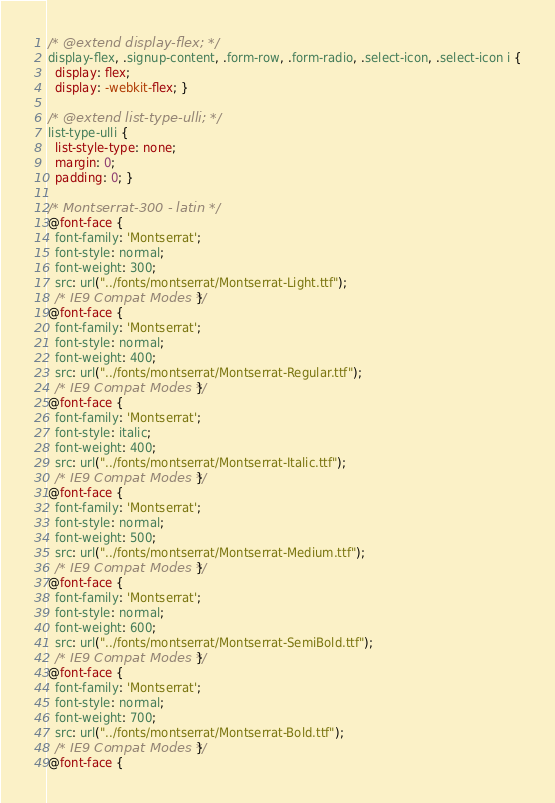Convert code to text. <code><loc_0><loc_0><loc_500><loc_500><_CSS_>/* @extend display-flex; */
display-flex, .signup-content, .form-row, .form-radio, .select-icon, .select-icon i {
  display: flex;
  display: -webkit-flex; }

/* @extend list-type-ulli; */
list-type-ulli {
  list-style-type: none;
  margin: 0;
  padding: 0; }

/* Montserrat-300 - latin */
@font-face {
  font-family: 'Montserrat';
  font-style: normal;
  font-weight: 300;
  src: url("../fonts/montserrat/Montserrat-Light.ttf");
  /* IE9 Compat Modes */ }
@font-face {
  font-family: 'Montserrat';
  font-style: normal;
  font-weight: 400;
  src: url("../fonts/montserrat/Montserrat-Regular.ttf");
  /* IE9 Compat Modes */ }
@font-face {
  font-family: 'Montserrat';
  font-style: italic;
  font-weight: 400;
  src: url("../fonts/montserrat/Montserrat-Italic.ttf");
  /* IE9 Compat Modes */ }
@font-face {
  font-family: 'Montserrat';
  font-style: normal;
  font-weight: 500;
  src: url("../fonts/montserrat/Montserrat-Medium.ttf");
  /* IE9 Compat Modes */ }
@font-face {
  font-family: 'Montserrat';
  font-style: normal;
  font-weight: 600;
  src: url("../fonts/montserrat/Montserrat-SemiBold.ttf");
  /* IE9 Compat Modes */ }
@font-face {
  font-family: 'Montserrat';
  font-style: normal;
  font-weight: 700;
  src: url("../fonts/montserrat/Montserrat-Bold.ttf");
  /* IE9 Compat Modes */ }
@font-face {</code> 